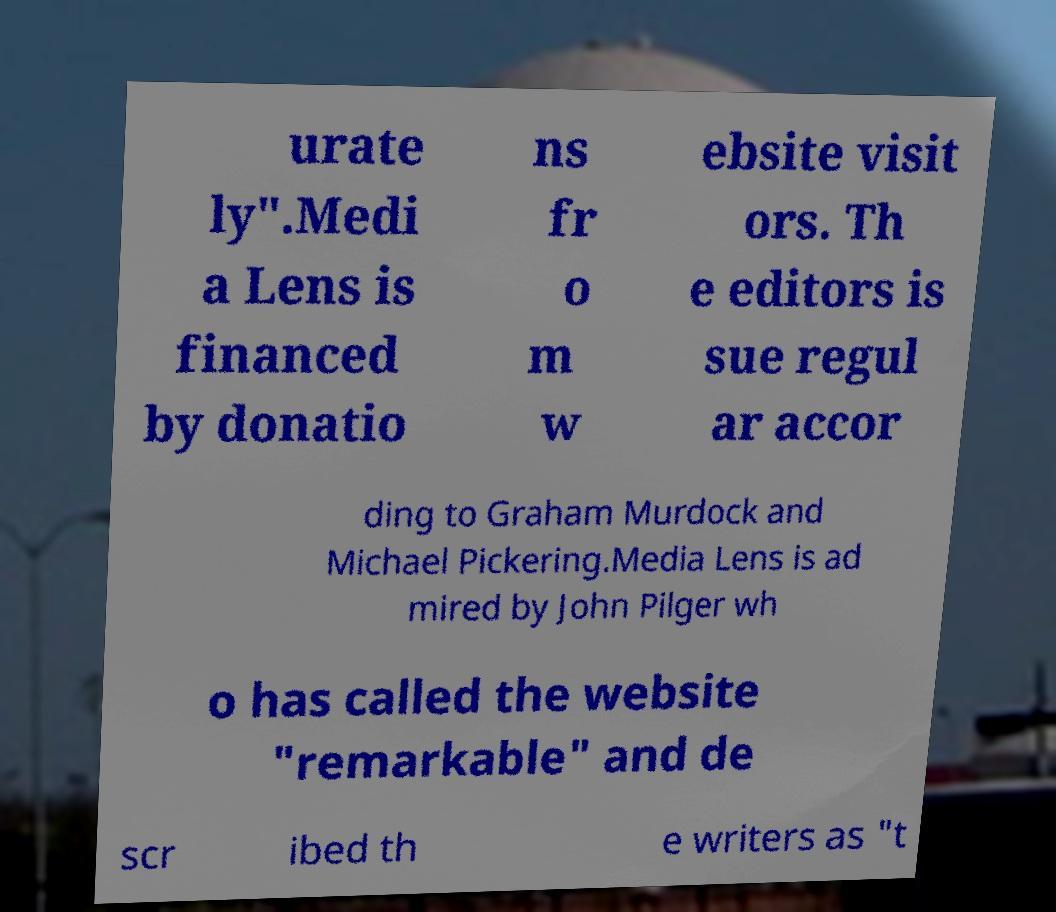There's text embedded in this image that I need extracted. Can you transcribe it verbatim? urate ly".Medi a Lens is financed by donatio ns fr o m w ebsite visit ors. Th e editors is sue regul ar accor ding to Graham Murdock and Michael Pickering.Media Lens is ad mired by John Pilger wh o has called the website "remarkable" and de scr ibed th e writers as "t 